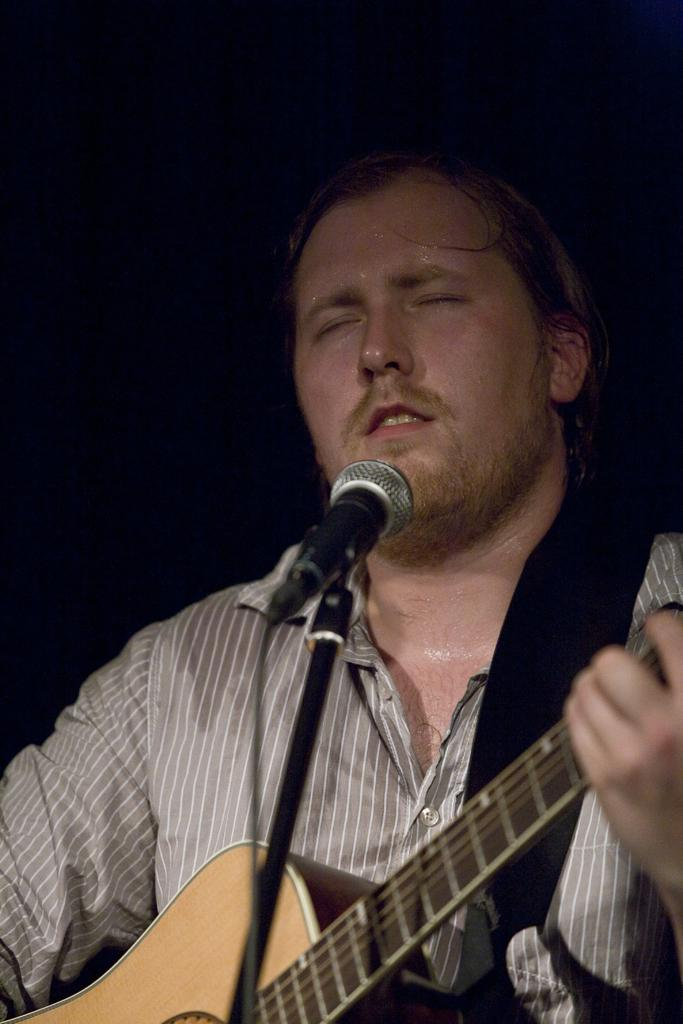What is the main subject of the image? There is a person in the image. What is the person doing in the image? The person is playing a guitar in front of a mic. What is the person wearing in the image? The person is wearing clothes in the image. What type of hole can be seen in the image? There is no hole present in the image. What kind of camera is being used by the person in the image? The image does not show any camera being used by the person. 